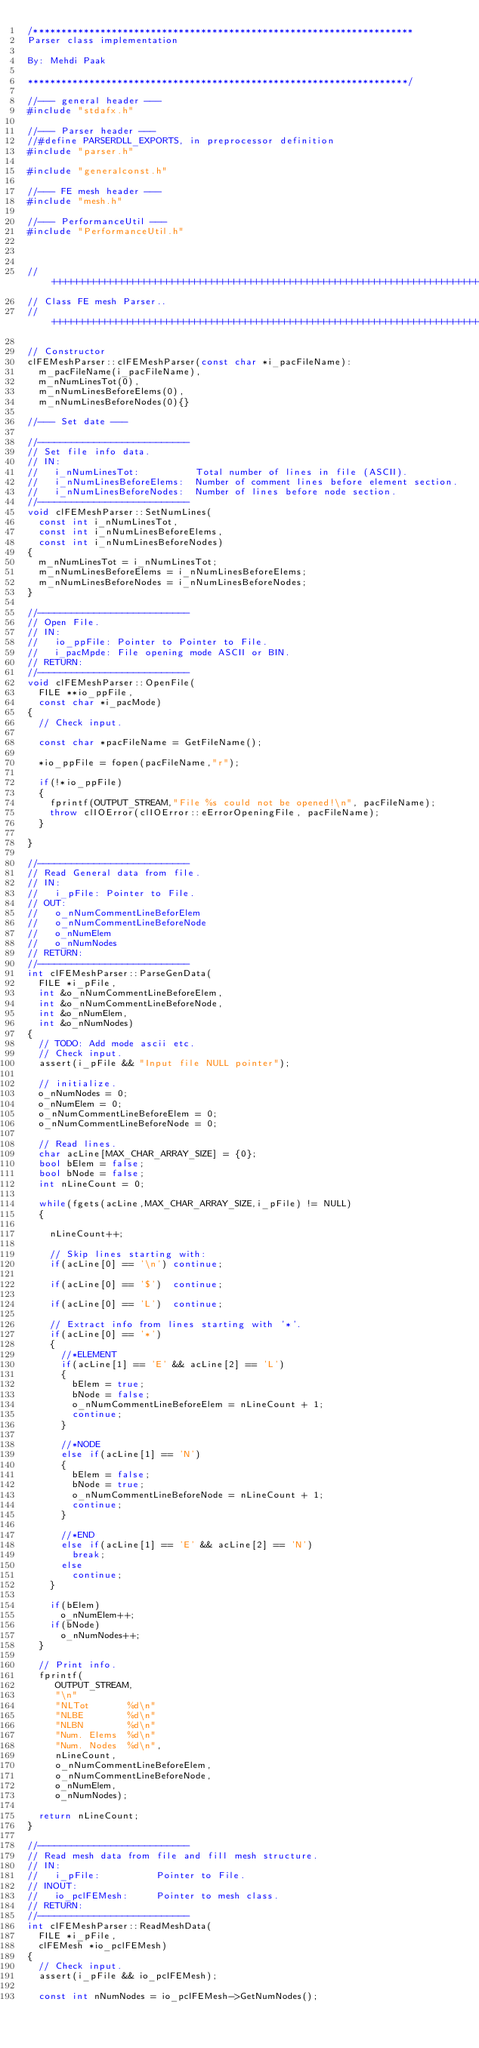Convert code to text. <code><loc_0><loc_0><loc_500><loc_500><_C++_>/********************************************************************
Parser class implementation

By: Mehdi Paak

********************************************************************/

//--- general header ---
#include "stdafx.h"

//--- Parser header ---
//#define PARSERDLL_EXPORTS, in preprocessor definition 
#include "parser.h"

#include "generalconst.h"

//--- FE mesh header ---
#include "mesh.h"

//--- PerformanceUtil ---
#include "PerformanceUtil.h"



//++++++++++++++++++++++++++++++++++++++++++++++++++++++++++++++++++++++++++++++++
// Class FE mesh Parser..
//++++++++++++++++++++++++++++++++++++++++++++++++++++++++++++++++++++++++++++++++

// Constructor
clFEMeshParser::clFEMeshParser(const char *i_pacFileName): 
  m_pacFileName(i_pacFileName), 
  m_nNumLinesTot(0), 
  m_nNumLinesBeforeElems(0), 
  m_nNumLinesBeforeNodes(0){}

//--- Set date ---

//---------------------------
// Set file info data.
// IN:
//   i_nNumLinesTot:          Total number of lines in file (ASCII).
//   i_nNumLinesBeforeElems:  Number of comment lines before element section.
//   i_nNumLinesBeforeNodes:  Number of lines before node section.
//---------------------------
void clFEMeshParser::SetNumLines(
  const int i_nNumLinesTot,
  const int i_nNumLinesBeforeElems,
  const int i_nNumLinesBeforeNodes)
{
  m_nNumLinesTot = i_nNumLinesTot;
  m_nNumLinesBeforeElems = i_nNumLinesBeforeElems;
  m_nNumLinesBeforeNodes = i_nNumLinesBeforeNodes;
}

//---------------------------
// Open File.
// IN:
//   io_ppFile: Pointer to Pointer to File.
//   i_pacMpde: File opening mode ASCII or BIN.
// RETURN:
//---------------------------
void clFEMeshParser::OpenFile(
  FILE **io_ppFile,
  const char *i_pacMode)
{
  // Check input.

  const char *pacFileName = GetFileName();

  *io_ppFile = fopen(pacFileName,"r");
  
  if(!*io_ppFile)
  {
    fprintf(OUTPUT_STREAM,"File %s could not be opened!\n", pacFileName);
    throw clIOError(clIOError::eErrorOpeningFile, pacFileName);
  }

}

//---------------------------
// Read General data from file.
// IN:
//   i_pFile: Pointer to File.
// OUT:
//   o_nNumCommentLineBeforElem
//   o_nNumCommentLineBeforeNode
//   o_nNumElem
//   o_nNumNodes
// RETURN:
//---------------------------
int clFEMeshParser::ParseGenData(
  FILE *i_pFile,
  int &o_nNumCommentLineBeforeElem,
  int &o_nNumCommentLineBeforeNode,
  int &o_nNumElem,
  int &o_nNumNodes)
{
  // TODO: Add mode ascii etc.
  // Check input.
  assert(i_pFile && "Input file NULL pointer");

  // initialize.
  o_nNumNodes = 0;
  o_nNumElem = 0;
  o_nNumCommentLineBeforeElem = 0;
  o_nNumCommentLineBeforeNode = 0;

  // Read lines.
  char acLine[MAX_CHAR_ARRAY_SIZE] = {0};
  bool bElem = false;
  bool bNode = false;
  int nLineCount = 0;

  while(fgets(acLine,MAX_CHAR_ARRAY_SIZE,i_pFile) != NULL)
  {
    
    nLineCount++;

    // Skip lines starting with:
    if(acLine[0] == '\n') continue;  
    
    if(acLine[0] == '$')  continue;
    
    if(acLine[0] == 'L')  continue;

    // Extract info from lines starting with '*'.
    if(acLine[0] == '*')
    {
      //*ELEMENT
      if(acLine[1] == 'E' && acLine[2] == 'L')
      {
        bElem = true;
        bNode = false;
        o_nNumCommentLineBeforeElem = nLineCount + 1;
        continue;
      }

      //*NODE
      else if(acLine[1] == 'N')
      {
        bElem = false;
        bNode = true;
        o_nNumCommentLineBeforeNode = nLineCount + 1;
        continue;
      }

      //*END
      else if(acLine[1] == 'E' && acLine[2] == 'N')
        break;
      else
        continue;
    }
    
    if(bElem) 
      o_nNumElem++;
    if(bNode)
      o_nNumNodes++;
  }

  // Print info.
  fprintf(
     OUTPUT_STREAM,
     "\n"
     "NLTot       %d\n"
     "NLBE        %d\n"
     "NLBN        %d\n"
     "Num. Elems  %d\n"
     "Num. Nodes  %d\n",
     nLineCount,
     o_nNumCommentLineBeforeElem,
     o_nNumCommentLineBeforeNode,
     o_nNumElem,
     o_nNumNodes);

  return nLineCount;
}

//---------------------------
// Read mesh data from file and fill mesh structure.
// IN:
//   i_pFile:          Pointer to File.
// INOUT:
//   io_pclFEMesh:     Pointer to mesh class.
// RETURN:
//---------------------------
int clFEMeshParser::ReadMeshData(
  FILE *i_pFile,
  clFEMesh *io_pclFEMesh)
{
  // Check input.
  assert(i_pFile && io_pclFEMesh);

  const int nNumNodes = io_pclFEMesh->GetNumNodes();</code> 